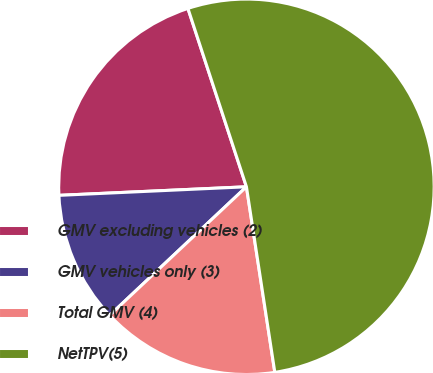Convert chart. <chart><loc_0><loc_0><loc_500><loc_500><pie_chart><fcel>GMV excluding vehicles (2)<fcel>GMV vehicles only (3)<fcel>Total GMV (4)<fcel>NetTPV(5)<nl><fcel>20.68%<fcel>11.28%<fcel>15.41%<fcel>52.63%<nl></chart> 